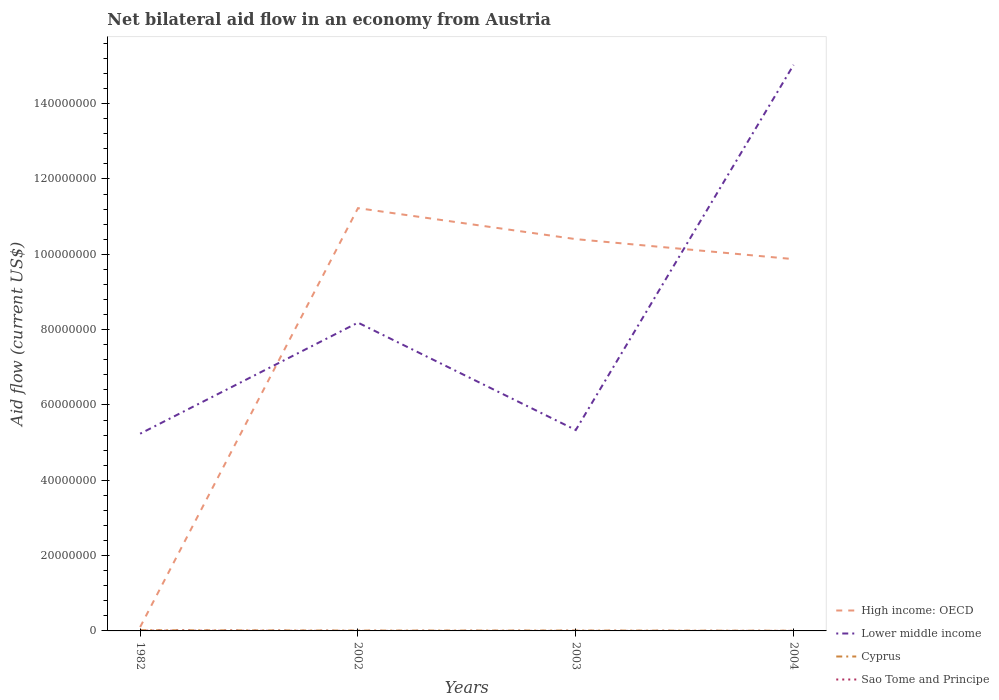Does the line corresponding to Sao Tome and Principe intersect with the line corresponding to Lower middle income?
Your answer should be compact. No. Across all years, what is the maximum net bilateral aid flow in Lower middle income?
Your response must be concise. 5.24e+07. What is the total net bilateral aid flow in High income: OECD in the graph?
Give a very brief answer. 5.31e+06. What is the difference between the highest and the second highest net bilateral aid flow in Sao Tome and Principe?
Make the answer very short. 6.00e+04. How many lines are there?
Ensure brevity in your answer.  4. What is the difference between two consecutive major ticks on the Y-axis?
Your response must be concise. 2.00e+07. Are the values on the major ticks of Y-axis written in scientific E-notation?
Provide a succinct answer. No. Does the graph contain grids?
Provide a succinct answer. No. How many legend labels are there?
Provide a succinct answer. 4. How are the legend labels stacked?
Provide a short and direct response. Vertical. What is the title of the graph?
Keep it short and to the point. Net bilateral aid flow in an economy from Austria. What is the label or title of the Y-axis?
Offer a terse response. Aid flow (current US$). What is the Aid flow (current US$) in High income: OECD in 1982?
Keep it short and to the point. 1.03e+06. What is the Aid flow (current US$) in Lower middle income in 1982?
Ensure brevity in your answer.  5.24e+07. What is the Aid flow (current US$) in Cyprus in 1982?
Your answer should be very brief. 1.80e+05. What is the Aid flow (current US$) in Sao Tome and Principe in 1982?
Provide a short and direct response. 7.00e+04. What is the Aid flow (current US$) of High income: OECD in 2002?
Make the answer very short. 1.12e+08. What is the Aid flow (current US$) in Lower middle income in 2002?
Ensure brevity in your answer.  8.19e+07. What is the Aid flow (current US$) in Sao Tome and Principe in 2002?
Your answer should be very brief. 10000. What is the Aid flow (current US$) of High income: OECD in 2003?
Offer a very short reply. 1.04e+08. What is the Aid flow (current US$) in Lower middle income in 2003?
Provide a succinct answer. 5.33e+07. What is the Aid flow (current US$) in Sao Tome and Principe in 2003?
Provide a succinct answer. 10000. What is the Aid flow (current US$) of High income: OECD in 2004?
Offer a very short reply. 9.87e+07. What is the Aid flow (current US$) of Lower middle income in 2004?
Keep it short and to the point. 1.50e+08. Across all years, what is the maximum Aid flow (current US$) of High income: OECD?
Provide a short and direct response. 1.12e+08. Across all years, what is the maximum Aid flow (current US$) of Lower middle income?
Keep it short and to the point. 1.50e+08. Across all years, what is the maximum Aid flow (current US$) of Cyprus?
Keep it short and to the point. 1.80e+05. Across all years, what is the maximum Aid flow (current US$) of Sao Tome and Principe?
Offer a very short reply. 7.00e+04. Across all years, what is the minimum Aid flow (current US$) of High income: OECD?
Your answer should be compact. 1.03e+06. Across all years, what is the minimum Aid flow (current US$) of Lower middle income?
Provide a short and direct response. 5.24e+07. What is the total Aid flow (current US$) of High income: OECD in the graph?
Give a very brief answer. 3.16e+08. What is the total Aid flow (current US$) of Lower middle income in the graph?
Offer a terse response. 3.38e+08. What is the total Aid flow (current US$) of Cyprus in the graph?
Keep it short and to the point. 4.20e+05. What is the total Aid flow (current US$) of Sao Tome and Principe in the graph?
Ensure brevity in your answer.  1.00e+05. What is the difference between the Aid flow (current US$) in High income: OECD in 1982 and that in 2002?
Provide a short and direct response. -1.11e+08. What is the difference between the Aid flow (current US$) in Lower middle income in 1982 and that in 2002?
Provide a short and direct response. -2.95e+07. What is the difference between the Aid flow (current US$) of Cyprus in 1982 and that in 2002?
Make the answer very short. 9.00e+04. What is the difference between the Aid flow (current US$) in Sao Tome and Principe in 1982 and that in 2002?
Make the answer very short. 6.00e+04. What is the difference between the Aid flow (current US$) of High income: OECD in 1982 and that in 2003?
Your response must be concise. -1.03e+08. What is the difference between the Aid flow (current US$) of Lower middle income in 1982 and that in 2003?
Offer a terse response. -9.70e+05. What is the difference between the Aid flow (current US$) in Cyprus in 1982 and that in 2003?
Provide a short and direct response. 8.00e+04. What is the difference between the Aid flow (current US$) of High income: OECD in 1982 and that in 2004?
Offer a very short reply. -9.77e+07. What is the difference between the Aid flow (current US$) of Lower middle income in 1982 and that in 2004?
Provide a succinct answer. -9.79e+07. What is the difference between the Aid flow (current US$) in High income: OECD in 2002 and that in 2003?
Offer a very short reply. 8.23e+06. What is the difference between the Aid flow (current US$) in Lower middle income in 2002 and that in 2003?
Keep it short and to the point. 2.85e+07. What is the difference between the Aid flow (current US$) in Cyprus in 2002 and that in 2003?
Your answer should be very brief. -10000. What is the difference between the Aid flow (current US$) in Sao Tome and Principe in 2002 and that in 2003?
Ensure brevity in your answer.  0. What is the difference between the Aid flow (current US$) in High income: OECD in 2002 and that in 2004?
Offer a terse response. 1.35e+07. What is the difference between the Aid flow (current US$) of Lower middle income in 2002 and that in 2004?
Make the answer very short. -6.84e+07. What is the difference between the Aid flow (current US$) in Sao Tome and Principe in 2002 and that in 2004?
Offer a very short reply. 0. What is the difference between the Aid flow (current US$) in High income: OECD in 2003 and that in 2004?
Provide a succinct answer. 5.31e+06. What is the difference between the Aid flow (current US$) in Lower middle income in 2003 and that in 2004?
Your answer should be very brief. -9.70e+07. What is the difference between the Aid flow (current US$) of Cyprus in 2003 and that in 2004?
Your response must be concise. 5.00e+04. What is the difference between the Aid flow (current US$) in Sao Tome and Principe in 2003 and that in 2004?
Provide a short and direct response. 0. What is the difference between the Aid flow (current US$) of High income: OECD in 1982 and the Aid flow (current US$) of Lower middle income in 2002?
Ensure brevity in your answer.  -8.08e+07. What is the difference between the Aid flow (current US$) of High income: OECD in 1982 and the Aid flow (current US$) of Cyprus in 2002?
Provide a short and direct response. 9.40e+05. What is the difference between the Aid flow (current US$) of High income: OECD in 1982 and the Aid flow (current US$) of Sao Tome and Principe in 2002?
Offer a terse response. 1.02e+06. What is the difference between the Aid flow (current US$) in Lower middle income in 1982 and the Aid flow (current US$) in Cyprus in 2002?
Provide a succinct answer. 5.23e+07. What is the difference between the Aid flow (current US$) of Lower middle income in 1982 and the Aid flow (current US$) of Sao Tome and Principe in 2002?
Make the answer very short. 5.24e+07. What is the difference between the Aid flow (current US$) of High income: OECD in 1982 and the Aid flow (current US$) of Lower middle income in 2003?
Your answer should be very brief. -5.23e+07. What is the difference between the Aid flow (current US$) of High income: OECD in 1982 and the Aid flow (current US$) of Cyprus in 2003?
Ensure brevity in your answer.  9.30e+05. What is the difference between the Aid flow (current US$) of High income: OECD in 1982 and the Aid flow (current US$) of Sao Tome and Principe in 2003?
Give a very brief answer. 1.02e+06. What is the difference between the Aid flow (current US$) of Lower middle income in 1982 and the Aid flow (current US$) of Cyprus in 2003?
Provide a succinct answer. 5.23e+07. What is the difference between the Aid flow (current US$) in Lower middle income in 1982 and the Aid flow (current US$) in Sao Tome and Principe in 2003?
Provide a short and direct response. 5.24e+07. What is the difference between the Aid flow (current US$) of Cyprus in 1982 and the Aid flow (current US$) of Sao Tome and Principe in 2003?
Your response must be concise. 1.70e+05. What is the difference between the Aid flow (current US$) in High income: OECD in 1982 and the Aid flow (current US$) in Lower middle income in 2004?
Your response must be concise. -1.49e+08. What is the difference between the Aid flow (current US$) of High income: OECD in 1982 and the Aid flow (current US$) of Cyprus in 2004?
Offer a very short reply. 9.80e+05. What is the difference between the Aid flow (current US$) in High income: OECD in 1982 and the Aid flow (current US$) in Sao Tome and Principe in 2004?
Provide a short and direct response. 1.02e+06. What is the difference between the Aid flow (current US$) in Lower middle income in 1982 and the Aid flow (current US$) in Cyprus in 2004?
Your answer should be very brief. 5.23e+07. What is the difference between the Aid flow (current US$) in Lower middle income in 1982 and the Aid flow (current US$) in Sao Tome and Principe in 2004?
Offer a very short reply. 5.24e+07. What is the difference between the Aid flow (current US$) of Cyprus in 1982 and the Aid flow (current US$) of Sao Tome and Principe in 2004?
Give a very brief answer. 1.70e+05. What is the difference between the Aid flow (current US$) of High income: OECD in 2002 and the Aid flow (current US$) of Lower middle income in 2003?
Ensure brevity in your answer.  5.89e+07. What is the difference between the Aid flow (current US$) in High income: OECD in 2002 and the Aid flow (current US$) in Cyprus in 2003?
Your response must be concise. 1.12e+08. What is the difference between the Aid flow (current US$) of High income: OECD in 2002 and the Aid flow (current US$) of Sao Tome and Principe in 2003?
Offer a very short reply. 1.12e+08. What is the difference between the Aid flow (current US$) of Lower middle income in 2002 and the Aid flow (current US$) of Cyprus in 2003?
Ensure brevity in your answer.  8.18e+07. What is the difference between the Aid flow (current US$) of Lower middle income in 2002 and the Aid flow (current US$) of Sao Tome and Principe in 2003?
Your response must be concise. 8.18e+07. What is the difference between the Aid flow (current US$) of High income: OECD in 2002 and the Aid flow (current US$) of Lower middle income in 2004?
Your response must be concise. -3.80e+07. What is the difference between the Aid flow (current US$) of High income: OECD in 2002 and the Aid flow (current US$) of Cyprus in 2004?
Your answer should be compact. 1.12e+08. What is the difference between the Aid flow (current US$) of High income: OECD in 2002 and the Aid flow (current US$) of Sao Tome and Principe in 2004?
Make the answer very short. 1.12e+08. What is the difference between the Aid flow (current US$) in Lower middle income in 2002 and the Aid flow (current US$) in Cyprus in 2004?
Offer a very short reply. 8.18e+07. What is the difference between the Aid flow (current US$) in Lower middle income in 2002 and the Aid flow (current US$) in Sao Tome and Principe in 2004?
Offer a terse response. 8.18e+07. What is the difference between the Aid flow (current US$) of Cyprus in 2002 and the Aid flow (current US$) of Sao Tome and Principe in 2004?
Your answer should be very brief. 8.00e+04. What is the difference between the Aid flow (current US$) in High income: OECD in 2003 and the Aid flow (current US$) in Lower middle income in 2004?
Give a very brief answer. -4.63e+07. What is the difference between the Aid flow (current US$) in High income: OECD in 2003 and the Aid flow (current US$) in Cyprus in 2004?
Your answer should be compact. 1.04e+08. What is the difference between the Aid flow (current US$) of High income: OECD in 2003 and the Aid flow (current US$) of Sao Tome and Principe in 2004?
Your answer should be very brief. 1.04e+08. What is the difference between the Aid flow (current US$) of Lower middle income in 2003 and the Aid flow (current US$) of Cyprus in 2004?
Ensure brevity in your answer.  5.33e+07. What is the difference between the Aid flow (current US$) in Lower middle income in 2003 and the Aid flow (current US$) in Sao Tome and Principe in 2004?
Give a very brief answer. 5.33e+07. What is the difference between the Aid flow (current US$) in Cyprus in 2003 and the Aid flow (current US$) in Sao Tome and Principe in 2004?
Ensure brevity in your answer.  9.00e+04. What is the average Aid flow (current US$) of High income: OECD per year?
Ensure brevity in your answer.  7.90e+07. What is the average Aid flow (current US$) in Lower middle income per year?
Provide a succinct answer. 8.45e+07. What is the average Aid flow (current US$) in Cyprus per year?
Offer a terse response. 1.05e+05. What is the average Aid flow (current US$) in Sao Tome and Principe per year?
Provide a short and direct response. 2.50e+04. In the year 1982, what is the difference between the Aid flow (current US$) in High income: OECD and Aid flow (current US$) in Lower middle income?
Provide a short and direct response. -5.13e+07. In the year 1982, what is the difference between the Aid flow (current US$) of High income: OECD and Aid flow (current US$) of Cyprus?
Your answer should be very brief. 8.50e+05. In the year 1982, what is the difference between the Aid flow (current US$) of High income: OECD and Aid flow (current US$) of Sao Tome and Principe?
Provide a short and direct response. 9.60e+05. In the year 1982, what is the difference between the Aid flow (current US$) in Lower middle income and Aid flow (current US$) in Cyprus?
Give a very brief answer. 5.22e+07. In the year 1982, what is the difference between the Aid flow (current US$) in Lower middle income and Aid flow (current US$) in Sao Tome and Principe?
Provide a short and direct response. 5.23e+07. In the year 1982, what is the difference between the Aid flow (current US$) in Cyprus and Aid flow (current US$) in Sao Tome and Principe?
Provide a succinct answer. 1.10e+05. In the year 2002, what is the difference between the Aid flow (current US$) in High income: OECD and Aid flow (current US$) in Lower middle income?
Give a very brief answer. 3.04e+07. In the year 2002, what is the difference between the Aid flow (current US$) in High income: OECD and Aid flow (current US$) in Cyprus?
Provide a succinct answer. 1.12e+08. In the year 2002, what is the difference between the Aid flow (current US$) of High income: OECD and Aid flow (current US$) of Sao Tome and Principe?
Keep it short and to the point. 1.12e+08. In the year 2002, what is the difference between the Aid flow (current US$) of Lower middle income and Aid flow (current US$) of Cyprus?
Your answer should be compact. 8.18e+07. In the year 2002, what is the difference between the Aid flow (current US$) in Lower middle income and Aid flow (current US$) in Sao Tome and Principe?
Provide a succinct answer. 8.18e+07. In the year 2003, what is the difference between the Aid flow (current US$) in High income: OECD and Aid flow (current US$) in Lower middle income?
Give a very brief answer. 5.07e+07. In the year 2003, what is the difference between the Aid flow (current US$) in High income: OECD and Aid flow (current US$) in Cyprus?
Your response must be concise. 1.04e+08. In the year 2003, what is the difference between the Aid flow (current US$) of High income: OECD and Aid flow (current US$) of Sao Tome and Principe?
Give a very brief answer. 1.04e+08. In the year 2003, what is the difference between the Aid flow (current US$) in Lower middle income and Aid flow (current US$) in Cyprus?
Provide a succinct answer. 5.32e+07. In the year 2003, what is the difference between the Aid flow (current US$) in Lower middle income and Aid flow (current US$) in Sao Tome and Principe?
Give a very brief answer. 5.33e+07. In the year 2004, what is the difference between the Aid flow (current US$) of High income: OECD and Aid flow (current US$) of Lower middle income?
Offer a very short reply. -5.16e+07. In the year 2004, what is the difference between the Aid flow (current US$) in High income: OECD and Aid flow (current US$) in Cyprus?
Provide a short and direct response. 9.87e+07. In the year 2004, what is the difference between the Aid flow (current US$) of High income: OECD and Aid flow (current US$) of Sao Tome and Principe?
Give a very brief answer. 9.87e+07. In the year 2004, what is the difference between the Aid flow (current US$) of Lower middle income and Aid flow (current US$) of Cyprus?
Offer a terse response. 1.50e+08. In the year 2004, what is the difference between the Aid flow (current US$) of Lower middle income and Aid flow (current US$) of Sao Tome and Principe?
Offer a terse response. 1.50e+08. What is the ratio of the Aid flow (current US$) of High income: OECD in 1982 to that in 2002?
Offer a terse response. 0.01. What is the ratio of the Aid flow (current US$) in Lower middle income in 1982 to that in 2002?
Ensure brevity in your answer.  0.64. What is the ratio of the Aid flow (current US$) of High income: OECD in 1982 to that in 2003?
Give a very brief answer. 0.01. What is the ratio of the Aid flow (current US$) of Lower middle income in 1982 to that in 2003?
Offer a very short reply. 0.98. What is the ratio of the Aid flow (current US$) in Cyprus in 1982 to that in 2003?
Provide a short and direct response. 1.8. What is the ratio of the Aid flow (current US$) of High income: OECD in 1982 to that in 2004?
Give a very brief answer. 0.01. What is the ratio of the Aid flow (current US$) in Lower middle income in 1982 to that in 2004?
Offer a very short reply. 0.35. What is the ratio of the Aid flow (current US$) of Sao Tome and Principe in 1982 to that in 2004?
Your answer should be compact. 7. What is the ratio of the Aid flow (current US$) in High income: OECD in 2002 to that in 2003?
Your response must be concise. 1.08. What is the ratio of the Aid flow (current US$) in Lower middle income in 2002 to that in 2003?
Give a very brief answer. 1.53. What is the ratio of the Aid flow (current US$) of High income: OECD in 2002 to that in 2004?
Offer a very short reply. 1.14. What is the ratio of the Aid flow (current US$) of Lower middle income in 2002 to that in 2004?
Offer a terse response. 0.54. What is the ratio of the Aid flow (current US$) of Cyprus in 2002 to that in 2004?
Ensure brevity in your answer.  1.8. What is the ratio of the Aid flow (current US$) in Sao Tome and Principe in 2002 to that in 2004?
Provide a short and direct response. 1. What is the ratio of the Aid flow (current US$) in High income: OECD in 2003 to that in 2004?
Ensure brevity in your answer.  1.05. What is the ratio of the Aid flow (current US$) of Lower middle income in 2003 to that in 2004?
Provide a short and direct response. 0.35. What is the ratio of the Aid flow (current US$) in Cyprus in 2003 to that in 2004?
Give a very brief answer. 2. What is the difference between the highest and the second highest Aid flow (current US$) of High income: OECD?
Your answer should be very brief. 8.23e+06. What is the difference between the highest and the second highest Aid flow (current US$) in Lower middle income?
Give a very brief answer. 6.84e+07. What is the difference between the highest and the second highest Aid flow (current US$) in Sao Tome and Principe?
Your response must be concise. 6.00e+04. What is the difference between the highest and the lowest Aid flow (current US$) of High income: OECD?
Your response must be concise. 1.11e+08. What is the difference between the highest and the lowest Aid flow (current US$) in Lower middle income?
Your answer should be compact. 9.79e+07. What is the difference between the highest and the lowest Aid flow (current US$) in Cyprus?
Your response must be concise. 1.30e+05. What is the difference between the highest and the lowest Aid flow (current US$) in Sao Tome and Principe?
Keep it short and to the point. 6.00e+04. 